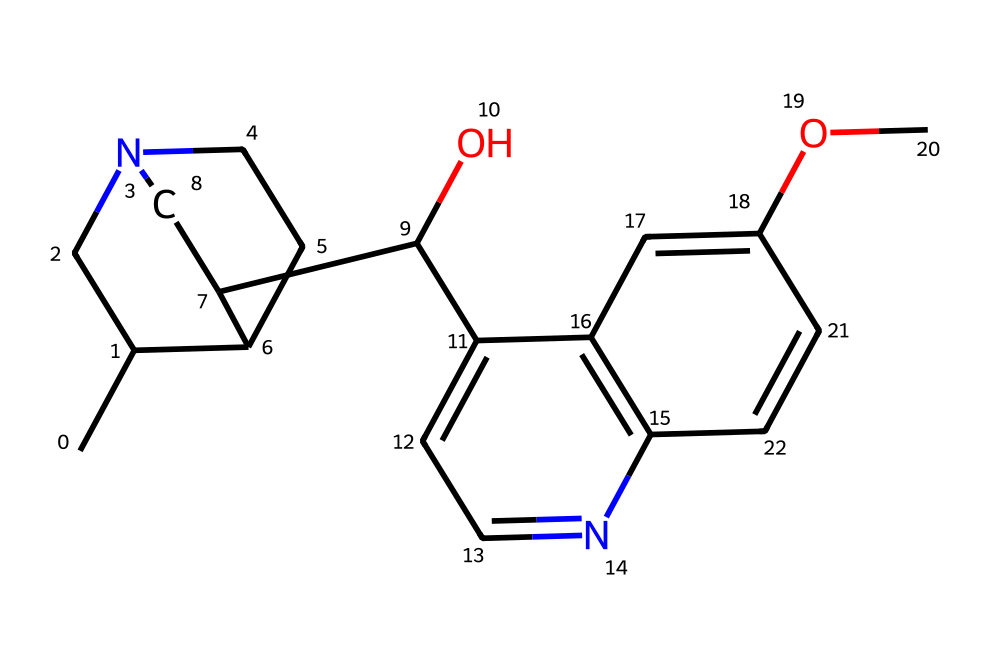What is the molecular formula of quinine? By counting the number of each type of atom in the SMILES representation, we see the presence of 20 carbon atoms, 24 hydrogen atoms, 1 nitrogen atom, and 1 oxygen atom. Thus, the molecular formula combines these counts for each element.
Answer: C20H24N2O2 How many rings are present in the structure of quinine? By examining the chemical structure indicated in the SMILES, we can identify the cyclic parts of the molecule. The visual representation allows one to count four interconnected rings in total.
Answer: 4 What functional groups can be identified in quinine? Assessing the SMILES notation reveals parts that indicate specific functional groups. There is a hydroxy group (indicated by "C(O)") and an ether-like linkage ("C(OC)"). Thus, the two primary functional groups present are a hydroxyl group and an ether.
Answer: hydroxyl and ether Which part of the molecular structure indicates the basicity of quinine? In the structure, the presence of the nitrogen atom manifests a region where the molecule can accept protons, which is characteristic of basic compounds. This nitrogen atom denotes the basicity within the structure.
Answer: nitrogen atom How does the presence of the nitrogen atom influence the pharmacological activity of quinine? This nitrogen atom is part of the alkaloid class of compounds known for their biological activity. It confers attributes such as binding affinity to certain receptors which are pivotal in the compound's antimalarial effects.
Answer: binding affinity 